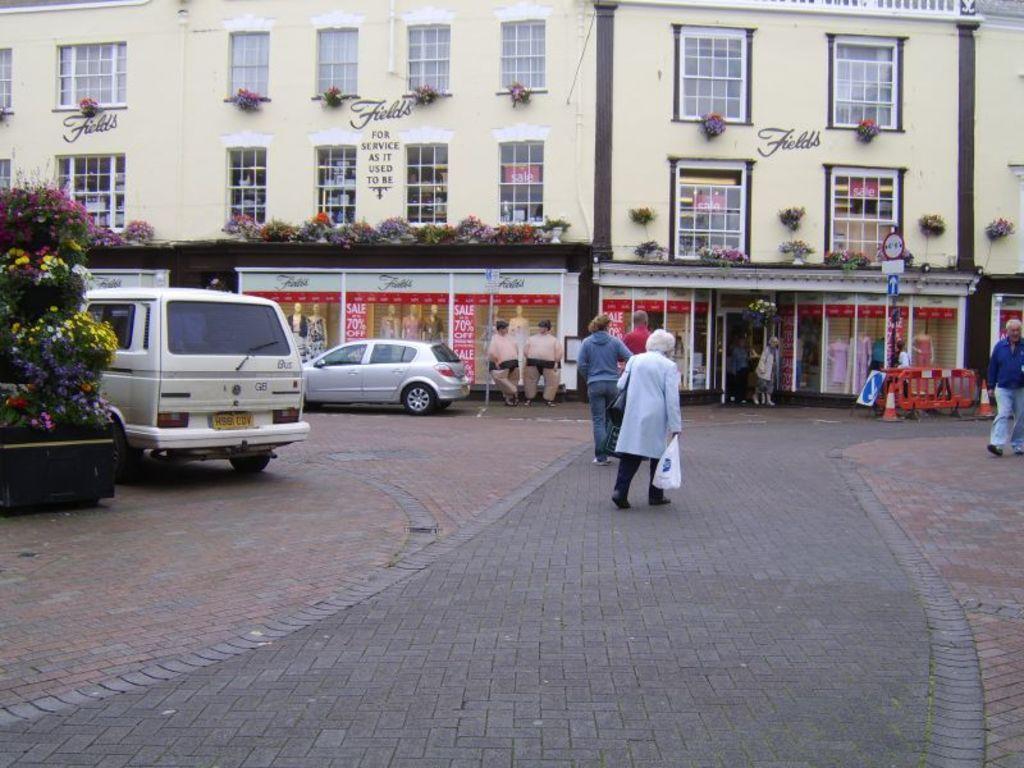Please provide a concise description of this image. In this image we can see walkway through which some persons are walking, on left side of the image there are some cars parked, there are some plants and in the background of the image there is a building on which there are some plants. 